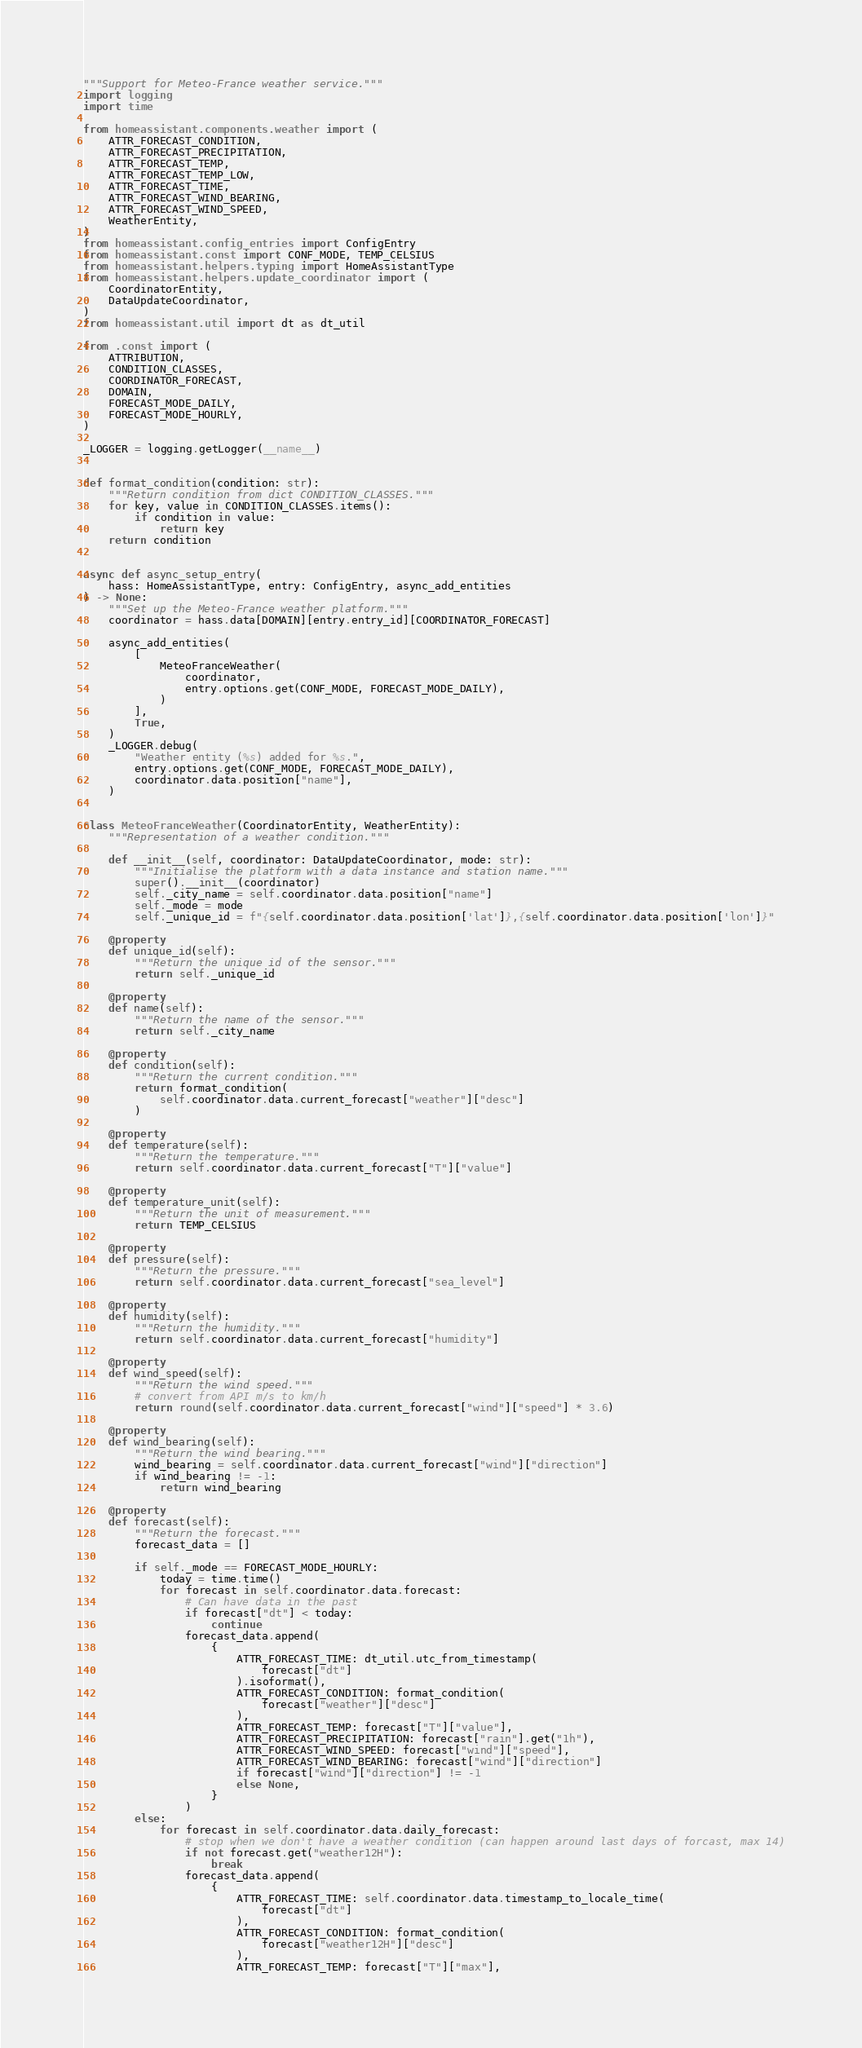Convert code to text. <code><loc_0><loc_0><loc_500><loc_500><_Python_>"""Support for Meteo-France weather service."""
import logging
import time

from homeassistant.components.weather import (
    ATTR_FORECAST_CONDITION,
    ATTR_FORECAST_PRECIPITATION,
    ATTR_FORECAST_TEMP,
    ATTR_FORECAST_TEMP_LOW,
    ATTR_FORECAST_TIME,
    ATTR_FORECAST_WIND_BEARING,
    ATTR_FORECAST_WIND_SPEED,
    WeatherEntity,
)
from homeassistant.config_entries import ConfigEntry
from homeassistant.const import CONF_MODE, TEMP_CELSIUS
from homeassistant.helpers.typing import HomeAssistantType
from homeassistant.helpers.update_coordinator import (
    CoordinatorEntity,
    DataUpdateCoordinator,
)
from homeassistant.util import dt as dt_util

from .const import (
    ATTRIBUTION,
    CONDITION_CLASSES,
    COORDINATOR_FORECAST,
    DOMAIN,
    FORECAST_MODE_DAILY,
    FORECAST_MODE_HOURLY,
)

_LOGGER = logging.getLogger(__name__)


def format_condition(condition: str):
    """Return condition from dict CONDITION_CLASSES."""
    for key, value in CONDITION_CLASSES.items():
        if condition in value:
            return key
    return condition


async def async_setup_entry(
    hass: HomeAssistantType, entry: ConfigEntry, async_add_entities
) -> None:
    """Set up the Meteo-France weather platform."""
    coordinator = hass.data[DOMAIN][entry.entry_id][COORDINATOR_FORECAST]

    async_add_entities(
        [
            MeteoFranceWeather(
                coordinator,
                entry.options.get(CONF_MODE, FORECAST_MODE_DAILY),
            )
        ],
        True,
    )
    _LOGGER.debug(
        "Weather entity (%s) added for %s.",
        entry.options.get(CONF_MODE, FORECAST_MODE_DAILY),
        coordinator.data.position["name"],
    )


class MeteoFranceWeather(CoordinatorEntity, WeatherEntity):
    """Representation of a weather condition."""

    def __init__(self, coordinator: DataUpdateCoordinator, mode: str):
        """Initialise the platform with a data instance and station name."""
        super().__init__(coordinator)
        self._city_name = self.coordinator.data.position["name"]
        self._mode = mode
        self._unique_id = f"{self.coordinator.data.position['lat']},{self.coordinator.data.position['lon']}"

    @property
    def unique_id(self):
        """Return the unique id of the sensor."""
        return self._unique_id

    @property
    def name(self):
        """Return the name of the sensor."""
        return self._city_name

    @property
    def condition(self):
        """Return the current condition."""
        return format_condition(
            self.coordinator.data.current_forecast["weather"]["desc"]
        )

    @property
    def temperature(self):
        """Return the temperature."""
        return self.coordinator.data.current_forecast["T"]["value"]

    @property
    def temperature_unit(self):
        """Return the unit of measurement."""
        return TEMP_CELSIUS

    @property
    def pressure(self):
        """Return the pressure."""
        return self.coordinator.data.current_forecast["sea_level"]

    @property
    def humidity(self):
        """Return the humidity."""
        return self.coordinator.data.current_forecast["humidity"]

    @property
    def wind_speed(self):
        """Return the wind speed."""
        # convert from API m/s to km/h
        return round(self.coordinator.data.current_forecast["wind"]["speed"] * 3.6)

    @property
    def wind_bearing(self):
        """Return the wind bearing."""
        wind_bearing = self.coordinator.data.current_forecast["wind"]["direction"]
        if wind_bearing != -1:
            return wind_bearing

    @property
    def forecast(self):
        """Return the forecast."""
        forecast_data = []

        if self._mode == FORECAST_MODE_HOURLY:
            today = time.time()
            for forecast in self.coordinator.data.forecast:
                # Can have data in the past
                if forecast["dt"] < today:
                    continue
                forecast_data.append(
                    {
                        ATTR_FORECAST_TIME: dt_util.utc_from_timestamp(
                            forecast["dt"]
                        ).isoformat(),
                        ATTR_FORECAST_CONDITION: format_condition(
                            forecast["weather"]["desc"]
                        ),
                        ATTR_FORECAST_TEMP: forecast["T"]["value"],
                        ATTR_FORECAST_PRECIPITATION: forecast["rain"].get("1h"),
                        ATTR_FORECAST_WIND_SPEED: forecast["wind"]["speed"],
                        ATTR_FORECAST_WIND_BEARING: forecast["wind"]["direction"]
                        if forecast["wind"]["direction"] != -1
                        else None,
                    }
                )
        else:
            for forecast in self.coordinator.data.daily_forecast:
                # stop when we don't have a weather condition (can happen around last days of forcast, max 14)
                if not forecast.get("weather12H"):
                    break
                forecast_data.append(
                    {
                        ATTR_FORECAST_TIME: self.coordinator.data.timestamp_to_locale_time(
                            forecast["dt"]
                        ),
                        ATTR_FORECAST_CONDITION: format_condition(
                            forecast["weather12H"]["desc"]
                        ),
                        ATTR_FORECAST_TEMP: forecast["T"]["max"],</code> 